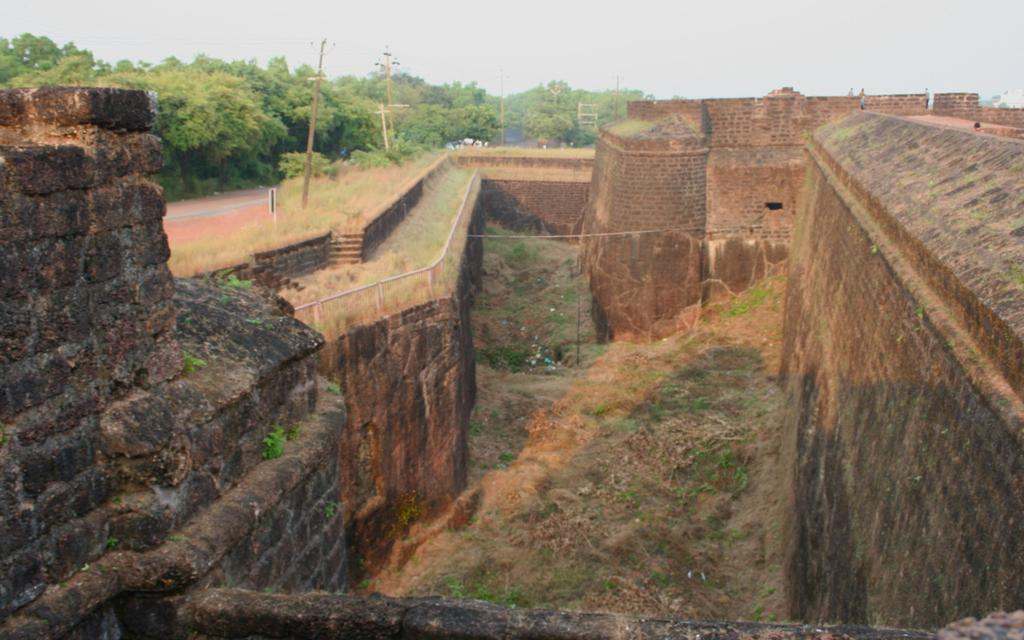What type of structure is in the picture? There is a fort in the picture. What is another feature present in the picture? There is a wall in the picture. What type of vegetation can be seen in the picture? There is grass in the picture. What are the poles used for in the picture? The purpose of the poles is not specified in the picture. What other natural elements are present in the picture? There are trees in the picture. What man-made feature is visible in the picture? There is a road in the picture. What can be seen in the background of the picture? The sky is visible in the background of the picture. What month is it in the picture? The month is not specified in the picture. How does the air affect the fort in the picture? The air does not have a direct effect on the fort in the picture. 